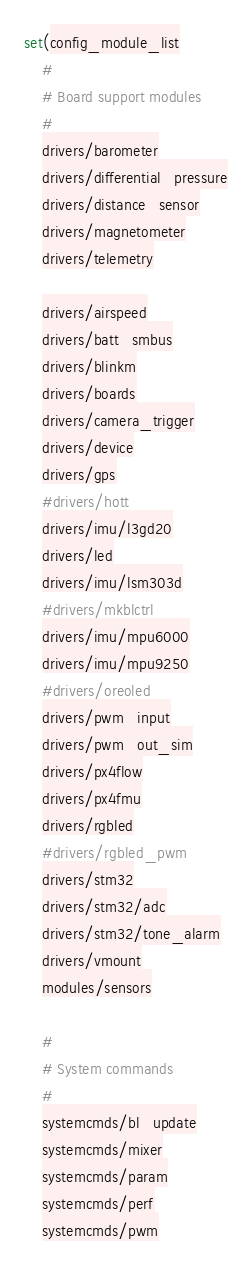<code> <loc_0><loc_0><loc_500><loc_500><_CMake_>
set(config_module_list
	#
	# Board support modules
	#
	drivers/barometer
	drivers/differential_pressure
	drivers/distance_sensor
	drivers/magnetometer
	drivers/telemetry

	drivers/airspeed
	drivers/batt_smbus
	drivers/blinkm
	drivers/boards
	drivers/camera_trigger
	drivers/device
	drivers/gps
	#drivers/hott
	drivers/imu/l3gd20
	drivers/led
	drivers/imu/lsm303d
	#drivers/mkblctrl
	drivers/imu/mpu6000
	drivers/imu/mpu9250
	#drivers/oreoled
	drivers/pwm_input
	drivers/pwm_out_sim
	drivers/px4flow
	drivers/px4fmu
	drivers/rgbled
	#drivers/rgbled_pwm
	drivers/stm32
	drivers/stm32/adc
	drivers/stm32/tone_alarm
	drivers/vmount
	modules/sensors

	#
	# System commands
	#
	systemcmds/bl_update
	systemcmds/mixer
	systemcmds/param
	systemcmds/perf
	systemcmds/pwm</code> 